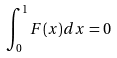Convert formula to latex. <formula><loc_0><loc_0><loc_500><loc_500>\int _ { 0 } ^ { 1 } F ( x ) d x = 0</formula> 